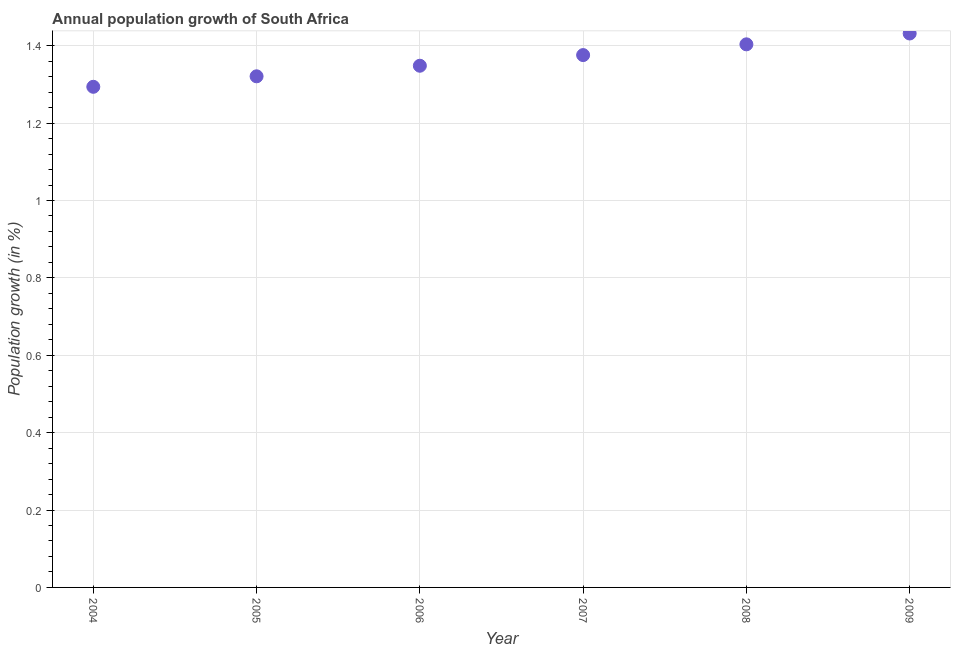What is the population growth in 2005?
Your answer should be very brief. 1.32. Across all years, what is the maximum population growth?
Give a very brief answer. 1.43. Across all years, what is the minimum population growth?
Provide a succinct answer. 1.29. In which year was the population growth maximum?
Keep it short and to the point. 2009. In which year was the population growth minimum?
Keep it short and to the point. 2004. What is the sum of the population growth?
Your answer should be very brief. 8.17. What is the difference between the population growth in 2006 and 2008?
Keep it short and to the point. -0.06. What is the average population growth per year?
Your answer should be compact. 1.36. What is the median population growth?
Provide a succinct answer. 1.36. In how many years, is the population growth greater than 0.8400000000000001 %?
Provide a short and direct response. 6. What is the ratio of the population growth in 2005 to that in 2008?
Give a very brief answer. 0.94. Is the population growth in 2004 less than that in 2007?
Provide a succinct answer. Yes. What is the difference between the highest and the second highest population growth?
Your answer should be very brief. 0.03. Is the sum of the population growth in 2007 and 2008 greater than the maximum population growth across all years?
Provide a succinct answer. Yes. What is the difference between the highest and the lowest population growth?
Your response must be concise. 0.14. In how many years, is the population growth greater than the average population growth taken over all years?
Provide a short and direct response. 3. How many years are there in the graph?
Your answer should be very brief. 6. Does the graph contain any zero values?
Offer a very short reply. No. Does the graph contain grids?
Offer a terse response. Yes. What is the title of the graph?
Your answer should be compact. Annual population growth of South Africa. What is the label or title of the X-axis?
Ensure brevity in your answer.  Year. What is the label or title of the Y-axis?
Make the answer very short. Population growth (in %). What is the Population growth (in %) in 2004?
Your answer should be very brief. 1.29. What is the Population growth (in %) in 2005?
Make the answer very short. 1.32. What is the Population growth (in %) in 2006?
Offer a very short reply. 1.35. What is the Population growth (in %) in 2007?
Keep it short and to the point. 1.38. What is the Population growth (in %) in 2008?
Make the answer very short. 1.4. What is the Population growth (in %) in 2009?
Make the answer very short. 1.43. What is the difference between the Population growth (in %) in 2004 and 2005?
Your response must be concise. -0.03. What is the difference between the Population growth (in %) in 2004 and 2006?
Offer a terse response. -0.05. What is the difference between the Population growth (in %) in 2004 and 2007?
Your answer should be very brief. -0.08. What is the difference between the Population growth (in %) in 2004 and 2008?
Ensure brevity in your answer.  -0.11. What is the difference between the Population growth (in %) in 2004 and 2009?
Ensure brevity in your answer.  -0.14. What is the difference between the Population growth (in %) in 2005 and 2006?
Keep it short and to the point. -0.03. What is the difference between the Population growth (in %) in 2005 and 2007?
Give a very brief answer. -0.05. What is the difference between the Population growth (in %) in 2005 and 2008?
Your answer should be very brief. -0.08. What is the difference between the Population growth (in %) in 2005 and 2009?
Offer a very short reply. -0.11. What is the difference between the Population growth (in %) in 2006 and 2007?
Keep it short and to the point. -0.03. What is the difference between the Population growth (in %) in 2006 and 2008?
Keep it short and to the point. -0.06. What is the difference between the Population growth (in %) in 2006 and 2009?
Provide a short and direct response. -0.08. What is the difference between the Population growth (in %) in 2007 and 2008?
Ensure brevity in your answer.  -0.03. What is the difference between the Population growth (in %) in 2007 and 2009?
Provide a short and direct response. -0.06. What is the difference between the Population growth (in %) in 2008 and 2009?
Provide a succinct answer. -0.03. What is the ratio of the Population growth (in %) in 2004 to that in 2006?
Provide a short and direct response. 0.96. What is the ratio of the Population growth (in %) in 2004 to that in 2008?
Offer a very short reply. 0.92. What is the ratio of the Population growth (in %) in 2004 to that in 2009?
Offer a very short reply. 0.9. What is the ratio of the Population growth (in %) in 2005 to that in 2006?
Ensure brevity in your answer.  0.98. What is the ratio of the Population growth (in %) in 2005 to that in 2008?
Give a very brief answer. 0.94. What is the ratio of the Population growth (in %) in 2005 to that in 2009?
Your answer should be very brief. 0.92. What is the ratio of the Population growth (in %) in 2006 to that in 2008?
Your answer should be very brief. 0.96. What is the ratio of the Population growth (in %) in 2006 to that in 2009?
Give a very brief answer. 0.94. What is the ratio of the Population growth (in %) in 2007 to that in 2009?
Your answer should be compact. 0.96. What is the ratio of the Population growth (in %) in 2008 to that in 2009?
Your response must be concise. 0.98. 